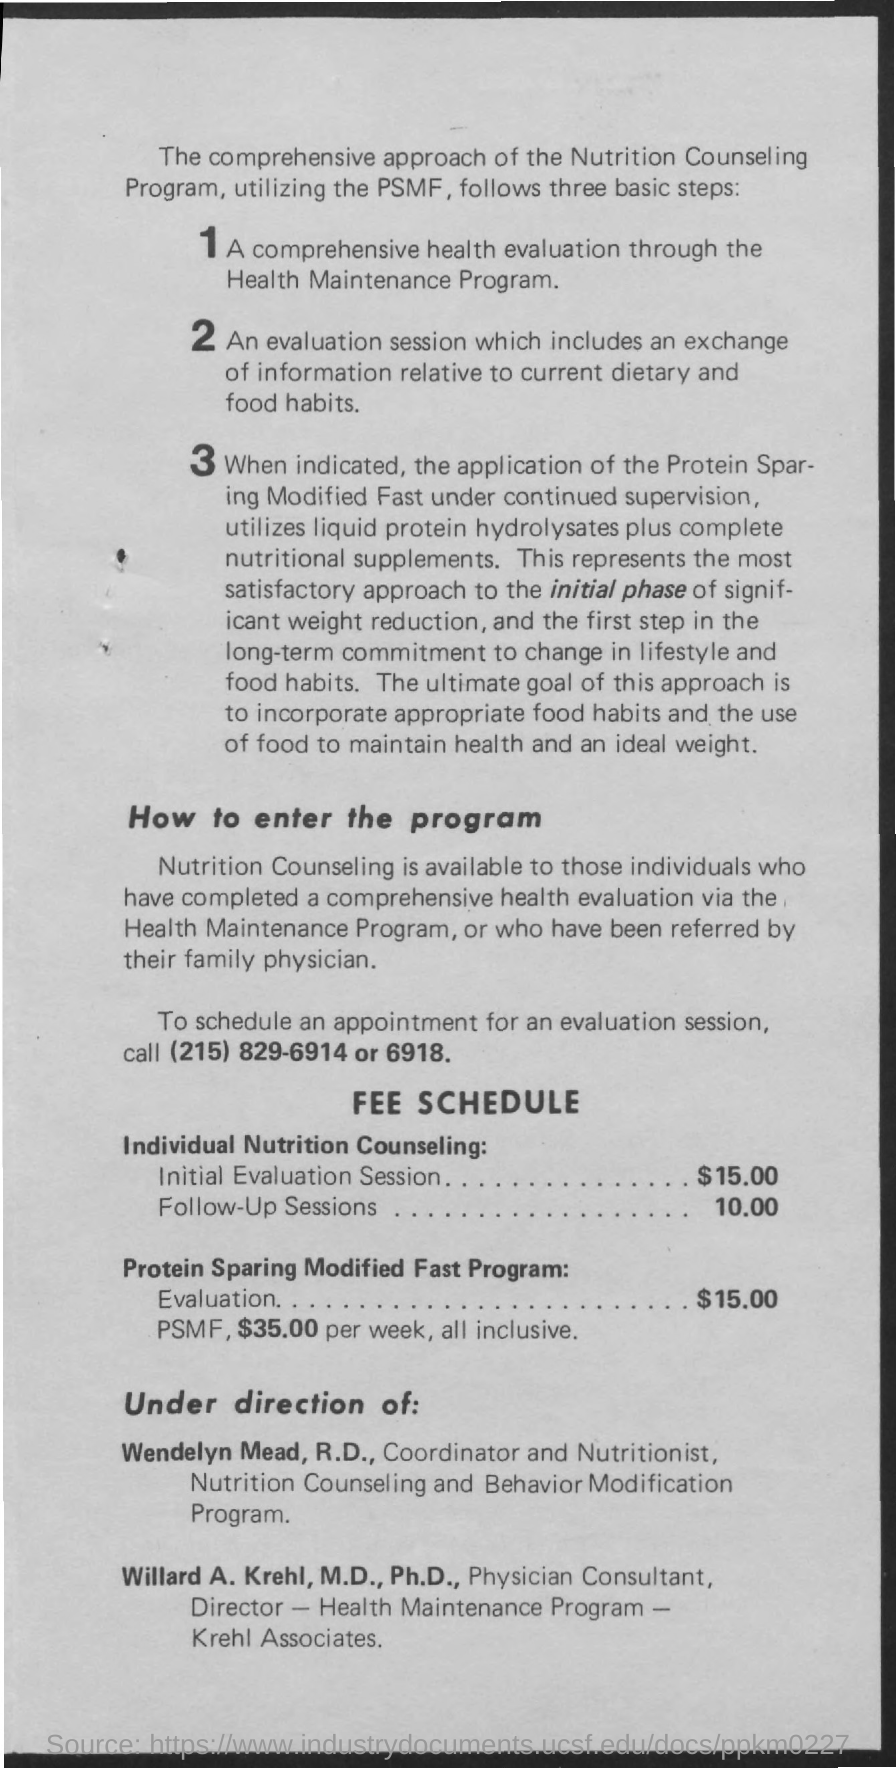Outline some significant characteristics in this image. The coordinator and nutritionist of the nutrition counseling and behavior modification program is Wendelyn Mead. The fee for the follow-up sessions in the individual nutrition counseling is $10.00. The initial evaluation session for individual nutrition counseling has a fee of $15.00. The cost for evaluation of the Protein Sparing Modified Fast (PSMF) program is $15.00. The number provided to schedule an evaluation appointment is (215) 829-6914 or 6918. 